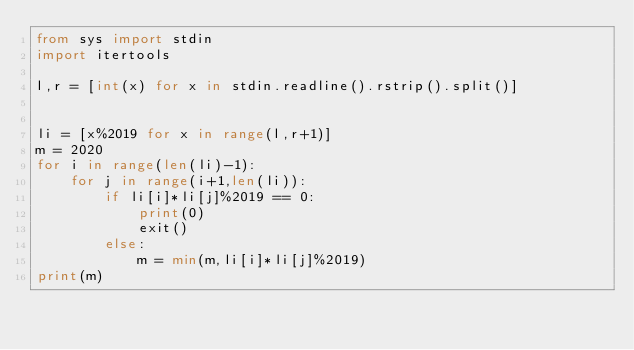Convert code to text. <code><loc_0><loc_0><loc_500><loc_500><_Python_>from sys import stdin
import itertools

l,r = [int(x) for x in stdin.readline().rstrip().split()]


li = [x%2019 for x in range(l,r+1)]
m = 2020
for i in range(len(li)-1):
    for j in range(i+1,len(li)):
        if li[i]*li[j]%2019 == 0:
            print(0)
            exit()
        else:
            m = min(m,li[i]*li[j]%2019)
print(m)</code> 